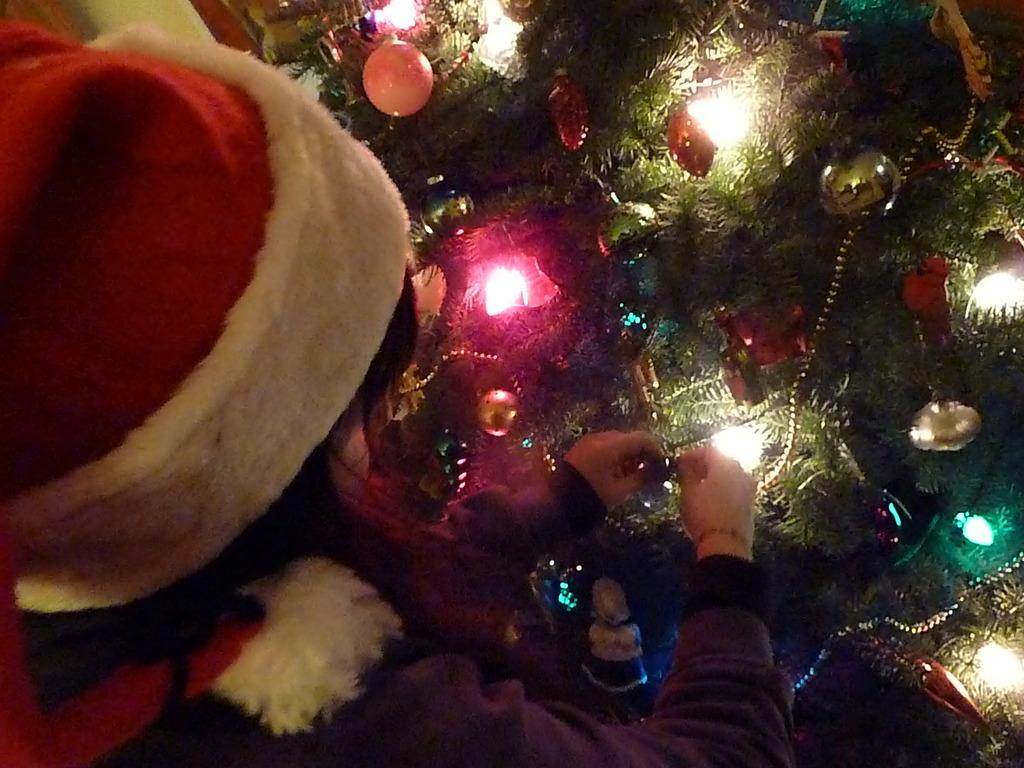What type of plant can be seen in the image? There is a tree in the image. Can you describe the person in the image? There is a person wearing a cap in the image. What type of bell can be seen hanging from the tree in the image? There is no bell present in the image; it only features a tree and a person wearing a cap. How many loaves of bread can be seen in the image? There are no loaves of bread present in the image. 